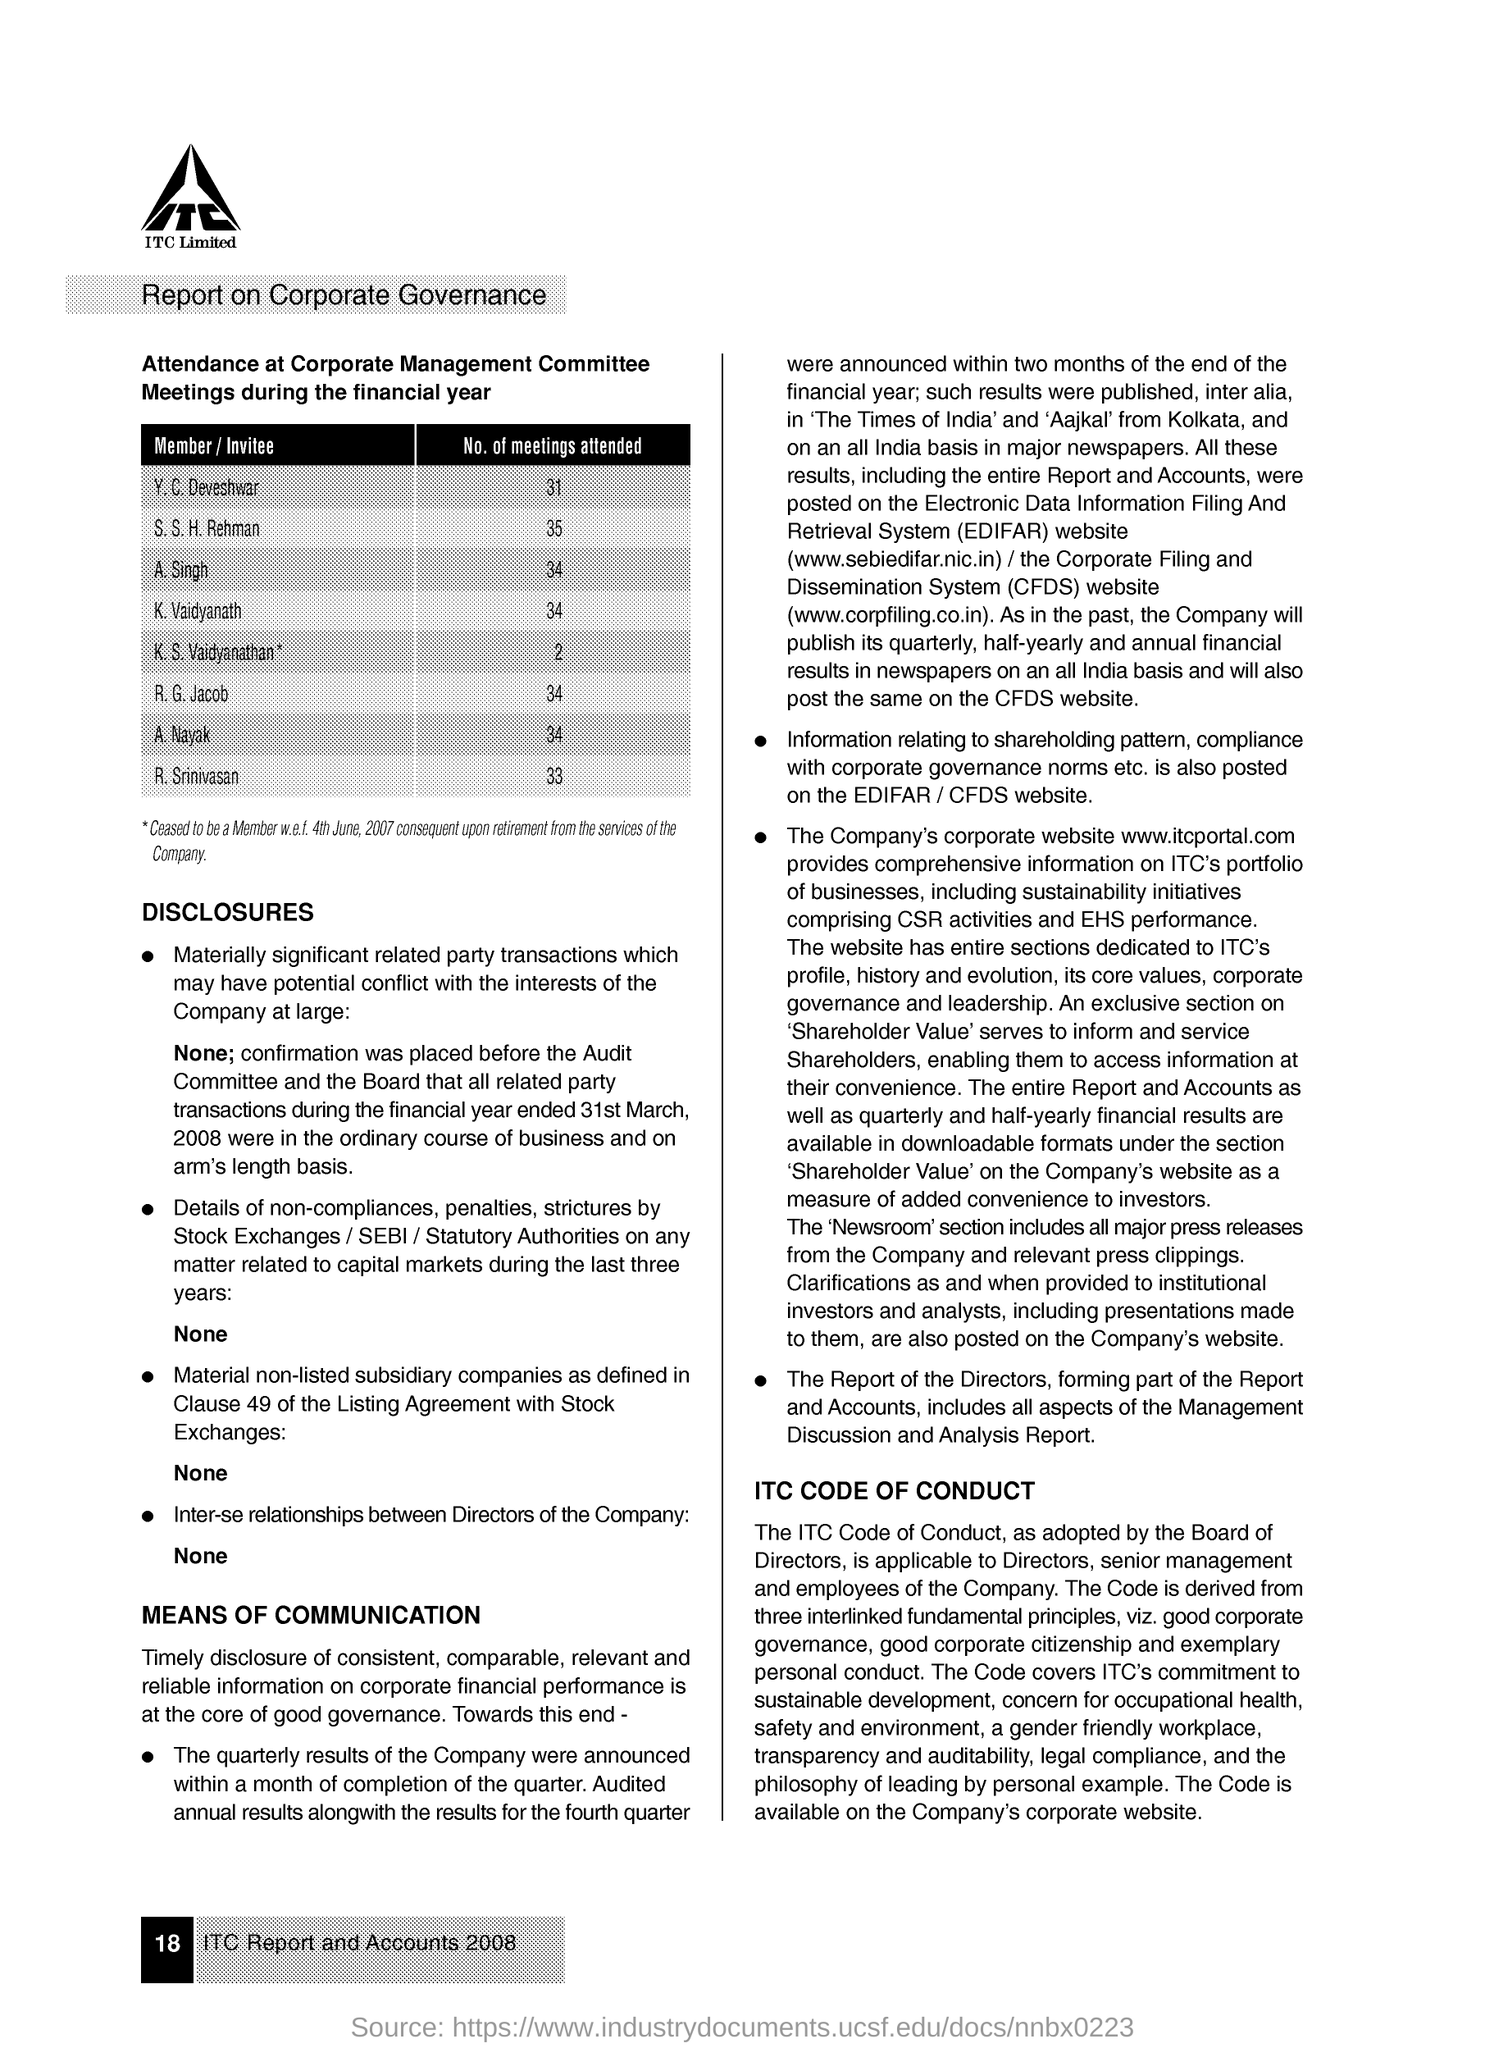How many meetings did Y.C.Deveshwar attend?
Give a very brief answer. 31. How many meetings did S.S.H.Rehman attend?
Provide a succinct answer. 35. How many meetings did A.Singh attend?
Make the answer very short. 34. How many meetings did K.Vaidyanath attend?
Offer a terse response. 34. How many meetings did K.S.Vaidyanathan attend?
Offer a very short reply. 2. How many meetings did R.G.Jacob attend?
Ensure brevity in your answer.  34. How many meetings did A.Nayak attend?
Keep it short and to the point. 34. How many meetings did R. Srinivasan attend?
Keep it short and to the point. 33. 